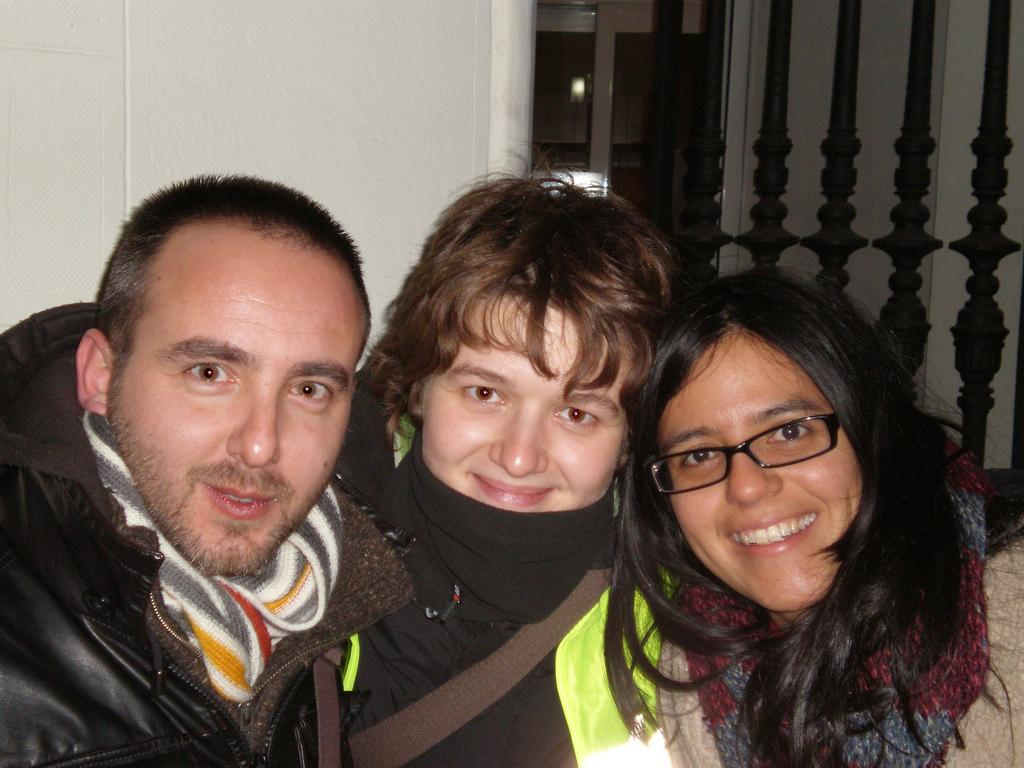Who or what is present in the image? There are people in the image. What is the emotional state of the people in the image? The people are smiling. What type of architectural features can be seen in the image? Walls and a railing are visible in the image. How does the river flow in the image? There is no river present in the image. Can you measure the distance between the people in the image? It is not possible to measure the distance between the people in the image without additional information, such as the size of the image or the people themselves. 